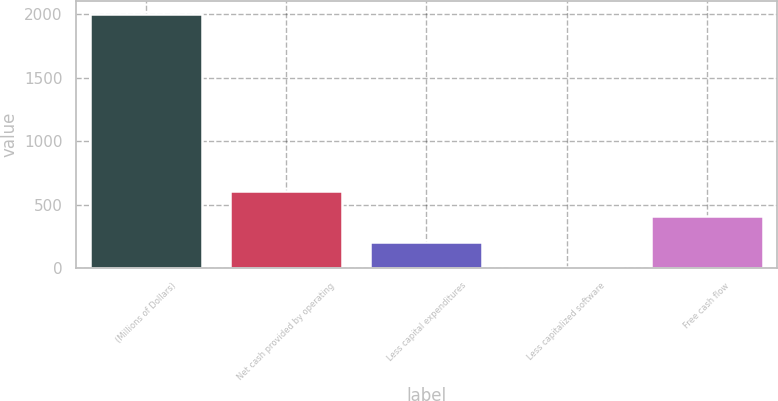Convert chart to OTSL. <chart><loc_0><loc_0><loc_500><loc_500><bar_chart><fcel>(Millions of Dollars)<fcel>Net cash provided by operating<fcel>Less capital expenditures<fcel>Less capitalized software<fcel>Free cash flow<nl><fcel>2004<fcel>606.1<fcel>206.7<fcel>7<fcel>406.4<nl></chart> 